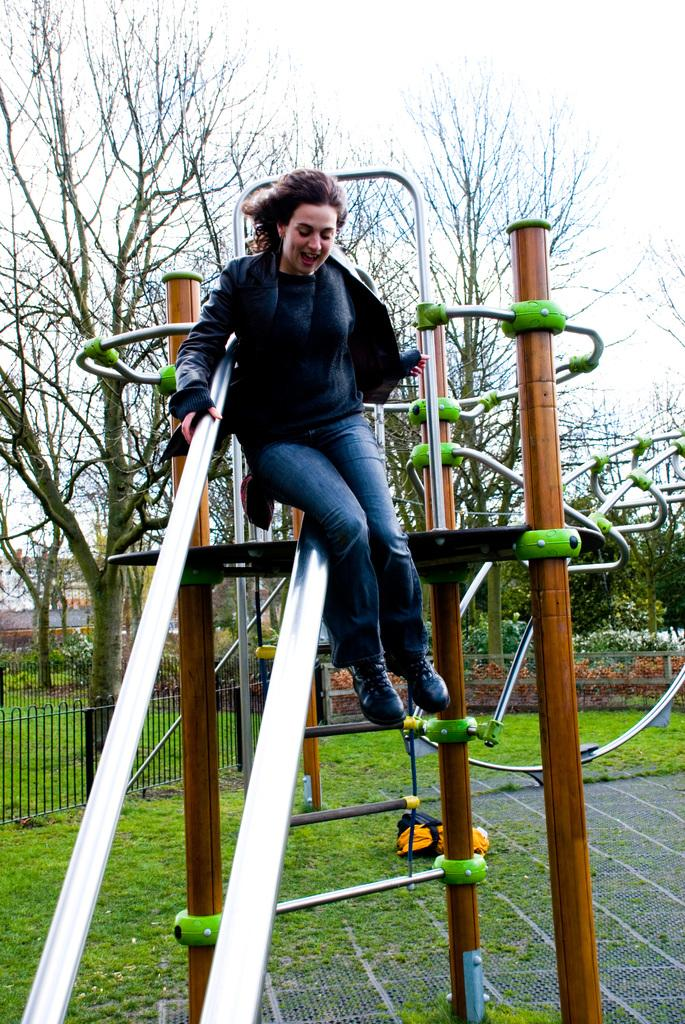Who is present in the image? There is a woman in the image. What is the woman sitting on? The woman is sitting on a steel object. What type of surface is visible on the ground? There is grass on the ground in the image. What can be seen in the background of the image? There are trees in the background of the image. How many pigs are visible in the image? There are no pigs present in the image. What is the size of the chain attached to the woman's ankle in the image? There is no chain attached to the woman's ankle in the image. 